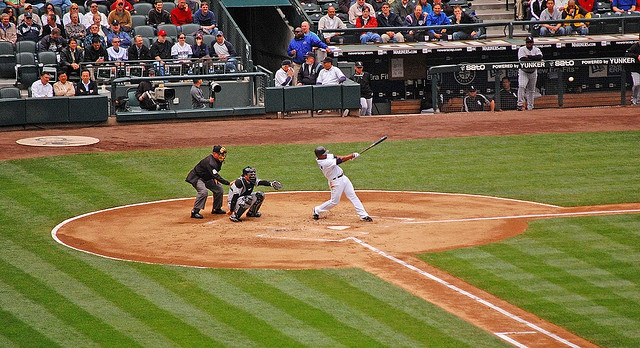Describe the objects in this image and their specific colors. I can see people in gray, black, lightgray, and darkgray tones, chair in gray, black, darkgray, and lightgray tones, people in gray, black, and maroon tones, people in gray, black, darkgray, and lightgray tones, and people in gray, lavender, darkgray, and lightpink tones in this image. 